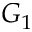<formula> <loc_0><loc_0><loc_500><loc_500>G _ { 1 }</formula> 